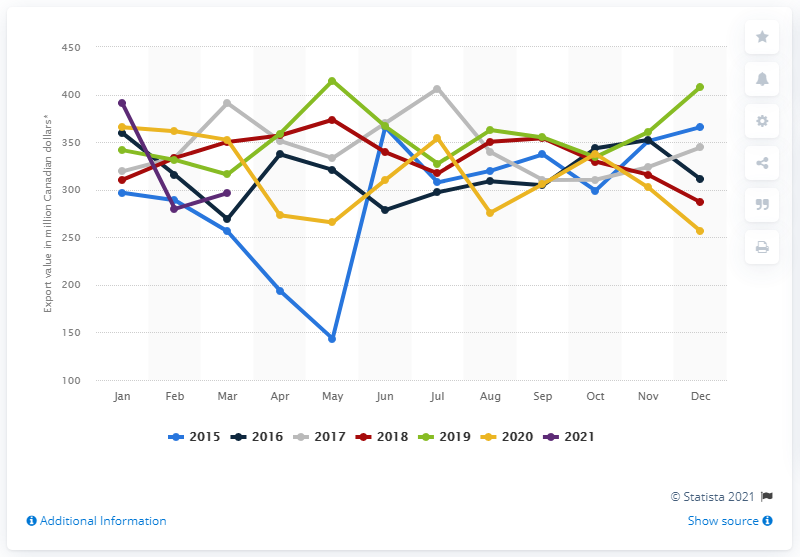Draw attention to some important aspects in this diagram. According to the data from March 2021, the export value of prepared and packaged seafood products from Canada was approximately 299 million dollars. 